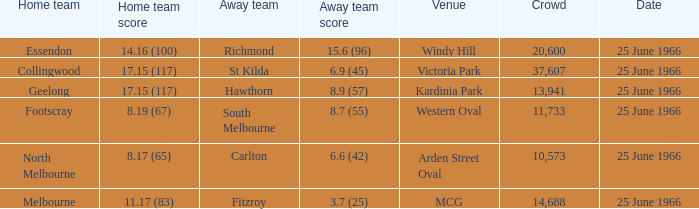What is the total crowd size when a home team scored 17.15 (117) versus hawthorn? 13941.0. 